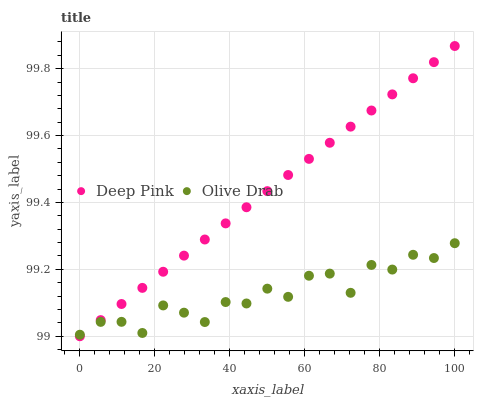Does Olive Drab have the minimum area under the curve?
Answer yes or no. Yes. Does Deep Pink have the maximum area under the curve?
Answer yes or no. Yes. Does Olive Drab have the maximum area under the curve?
Answer yes or no. No. Is Deep Pink the smoothest?
Answer yes or no. Yes. Is Olive Drab the roughest?
Answer yes or no. Yes. Is Olive Drab the smoothest?
Answer yes or no. No. Does Deep Pink have the lowest value?
Answer yes or no. Yes. Does Olive Drab have the lowest value?
Answer yes or no. No. Does Deep Pink have the highest value?
Answer yes or no. Yes. Does Olive Drab have the highest value?
Answer yes or no. No. Does Olive Drab intersect Deep Pink?
Answer yes or no. Yes. Is Olive Drab less than Deep Pink?
Answer yes or no. No. Is Olive Drab greater than Deep Pink?
Answer yes or no. No. 